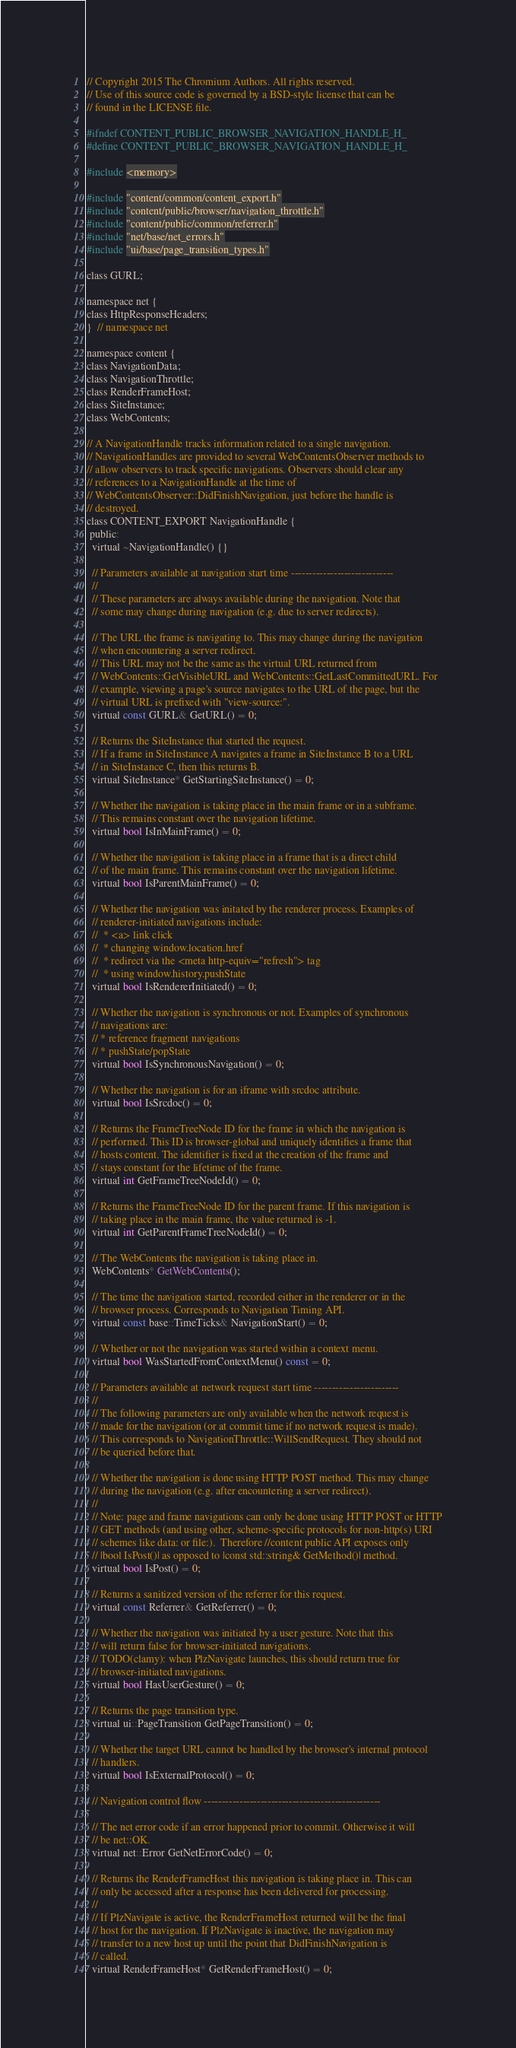Convert code to text. <code><loc_0><loc_0><loc_500><loc_500><_C_>// Copyright 2015 The Chromium Authors. All rights reserved.
// Use of this source code is governed by a BSD-style license that can be
// found in the LICENSE file.

#ifndef CONTENT_PUBLIC_BROWSER_NAVIGATION_HANDLE_H_
#define CONTENT_PUBLIC_BROWSER_NAVIGATION_HANDLE_H_

#include <memory>

#include "content/common/content_export.h"
#include "content/public/browser/navigation_throttle.h"
#include "content/public/common/referrer.h"
#include "net/base/net_errors.h"
#include "ui/base/page_transition_types.h"

class GURL;

namespace net {
class HttpResponseHeaders;
}  // namespace net

namespace content {
class NavigationData;
class NavigationThrottle;
class RenderFrameHost;
class SiteInstance;
class WebContents;

// A NavigationHandle tracks information related to a single navigation.
// NavigationHandles are provided to several WebContentsObserver methods to
// allow observers to track specific navigations. Observers should clear any
// references to a NavigationHandle at the time of
// WebContentsObserver::DidFinishNavigation, just before the handle is
// destroyed.
class CONTENT_EXPORT NavigationHandle {
 public:
  virtual ~NavigationHandle() {}

  // Parameters available at navigation start time -----------------------------
  //
  // These parameters are always available during the navigation. Note that
  // some may change during navigation (e.g. due to server redirects).

  // The URL the frame is navigating to. This may change during the navigation
  // when encountering a server redirect.
  // This URL may not be the same as the virtual URL returned from
  // WebContents::GetVisibleURL and WebContents::GetLastCommittedURL. For
  // example, viewing a page's source navigates to the URL of the page, but the
  // virtual URL is prefixed with "view-source:".
  virtual const GURL& GetURL() = 0;

  // Returns the SiteInstance that started the request.
  // If a frame in SiteInstance A navigates a frame in SiteInstance B to a URL
  // in SiteInstance C, then this returns B.
  virtual SiteInstance* GetStartingSiteInstance() = 0;

  // Whether the navigation is taking place in the main frame or in a subframe.
  // This remains constant over the navigation lifetime.
  virtual bool IsInMainFrame() = 0;

  // Whether the navigation is taking place in a frame that is a direct child
  // of the main frame. This remains constant over the navigation lifetime.
  virtual bool IsParentMainFrame() = 0;

  // Whether the navigation was initated by the renderer process. Examples of
  // renderer-initiated navigations include:
  //  * <a> link click
  //  * changing window.location.href
  //  * redirect via the <meta http-equiv="refresh"> tag
  //  * using window.history.pushState
  virtual bool IsRendererInitiated() = 0;

  // Whether the navigation is synchronous or not. Examples of synchronous
  // navigations are:
  // * reference fragment navigations
  // * pushState/popState
  virtual bool IsSynchronousNavigation() = 0;

  // Whether the navigation is for an iframe with srcdoc attribute.
  virtual bool IsSrcdoc() = 0;

  // Returns the FrameTreeNode ID for the frame in which the navigation is
  // performed. This ID is browser-global and uniquely identifies a frame that
  // hosts content. The identifier is fixed at the creation of the frame and
  // stays constant for the lifetime of the frame.
  virtual int GetFrameTreeNodeId() = 0;

  // Returns the FrameTreeNode ID for the parent frame. If this navigation is
  // taking place in the main frame, the value returned is -1.
  virtual int GetParentFrameTreeNodeId() = 0;

  // The WebContents the navigation is taking place in.
  WebContents* GetWebContents();

  // The time the navigation started, recorded either in the renderer or in the
  // browser process. Corresponds to Navigation Timing API.
  virtual const base::TimeTicks& NavigationStart() = 0;

  // Whether or not the navigation was started within a context menu.
  virtual bool WasStartedFromContextMenu() const = 0;

  // Parameters available at network request start time ------------------------
  //
  // The following parameters are only available when the network request is
  // made for the navigation (or at commit time if no network request is made).
  // This corresponds to NavigationThrottle::WillSendRequest. They should not
  // be queried before that.

  // Whether the navigation is done using HTTP POST method. This may change
  // during the navigation (e.g. after encountering a server redirect).
  //
  // Note: page and frame navigations can only be done using HTTP POST or HTTP
  // GET methods (and using other, scheme-specific protocols for non-http(s) URI
  // schemes like data: or file:).  Therefore //content public API exposes only
  // |bool IsPost()| as opposed to |const std::string& GetMethod()| method.
  virtual bool IsPost() = 0;

  // Returns a sanitized version of the referrer for this request.
  virtual const Referrer& GetReferrer() = 0;

  // Whether the navigation was initiated by a user gesture. Note that this
  // will return false for browser-initiated navigations.
  // TODO(clamy): when PlzNavigate launches, this should return true for
  // browser-initiated navigations.
  virtual bool HasUserGesture() = 0;

  // Returns the page transition type.
  virtual ui::PageTransition GetPageTransition() = 0;

  // Whether the target URL cannot be handled by the browser's internal protocol
  // handlers.
  virtual bool IsExternalProtocol() = 0;

  // Navigation control flow --------------------------------------------------

  // The net error code if an error happened prior to commit. Otherwise it will
  // be net::OK.
  virtual net::Error GetNetErrorCode() = 0;

  // Returns the RenderFrameHost this navigation is taking place in. This can
  // only be accessed after a response has been delivered for processing.
  //
  // If PlzNavigate is active, the RenderFrameHost returned will be the final
  // host for the navigation. If PlzNavigate is inactive, the navigation may
  // transfer to a new host up until the point that DidFinishNavigation is
  // called.
  virtual RenderFrameHost* GetRenderFrameHost() = 0;
</code> 